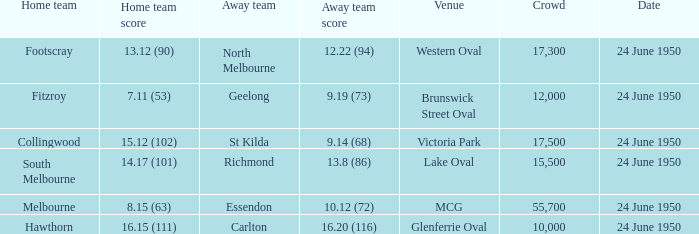In the game where north melbourne was the guest team, who was the host team? Footscray. 